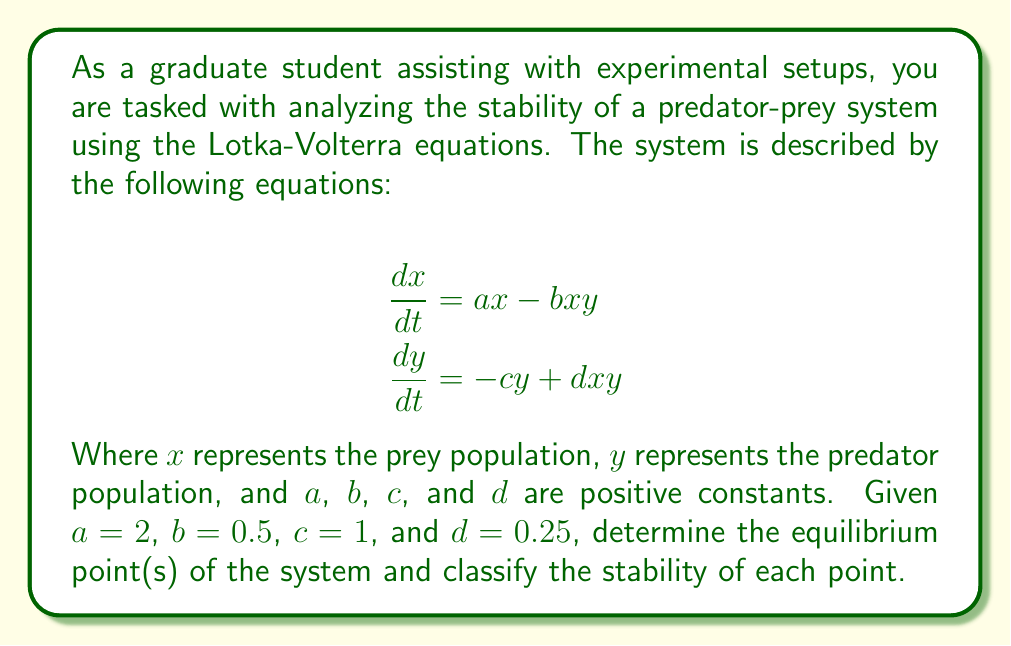Help me with this question. To analyze the stability of the predator-prey system, we'll follow these steps:

1. Find the equilibrium points by setting both equations equal to zero and solving for $x$ and $y$.

2. Calculate the Jacobian matrix of the system.

3. Evaluate the Jacobian matrix at each equilibrium point.

4. Determine the eigenvalues of the Jacobian matrix at each equilibrium point.

5. Classify the stability based on the eigenvalues.

Step 1: Finding equilibrium points

Set both equations to zero:
$$ax - bxy = 0$$
$$-cy + dxy = 0$$

Substituting the given values:
$$2x - 0.5xy = 0$$
$$-y + 0.25xy = 0$$

From the second equation:
$$y = 0 \text{ or } x = 4$$

If $y = 0$, then from the first equation:
$$2x = 0 \implies x = 0$$

If $x = 4$, then from the first equation:
$$8 - 2y = 0 \implies y = 4$$

Therefore, we have two equilibrium points: $(0, 0)$ and $(4, 4)$.

Step 2: Calculate the Jacobian matrix

The Jacobian matrix is:
$$J = \begin{bmatrix}
\frac{\partial}{\partial x}(ax - bxy) & \frac{\partial}{\partial y}(ax - bxy) \\
\frac{\partial}{\partial x}(-cy + dxy) & \frac{\partial}{\partial y}(-cy + dxy)
\end{bmatrix}$$

$$J = \begin{bmatrix}
a - by & -bx \\
dy & -c + dx
\end{bmatrix}$$

Step 3: Evaluate the Jacobian at each equilibrium point

At $(0, 0)$:
$$J_{(0,0)} = \begin{bmatrix}
2 & 0 \\
0 & -1
\end{bmatrix}$$

At $(4, 4)$:
$$J_{(4,4)} = \begin{bmatrix}
0 & -2 \\
1 & 0
\end{bmatrix}$$

Step 4: Determine the eigenvalues

For $(0, 0)$:
The eigenvalues are $\lambda_1 = 2$ and $\lambda_2 = -1$.

For $(4, 4)$:
The characteristic equation is $\lambda^2 + 2 = 0$
The eigenvalues are $\lambda_{1,2} = \pm i\sqrt{2}$.

Step 5: Classify stability

For $(0, 0)$:
Since one eigenvalue is positive and one is negative, this is a saddle point, which is unstable.

For $(4, 4)$:
The eigenvalues are purely imaginary conjugates, indicating a center. This point is neutrally stable, and solutions near this point will oscillate around it.
Answer: The system has two equilibrium points: $(0, 0)$ and $(4, 4)$. The point $(0, 0)$ is a saddle point and is unstable. The point $(4, 4)$ is a center and is neutrally stable. 